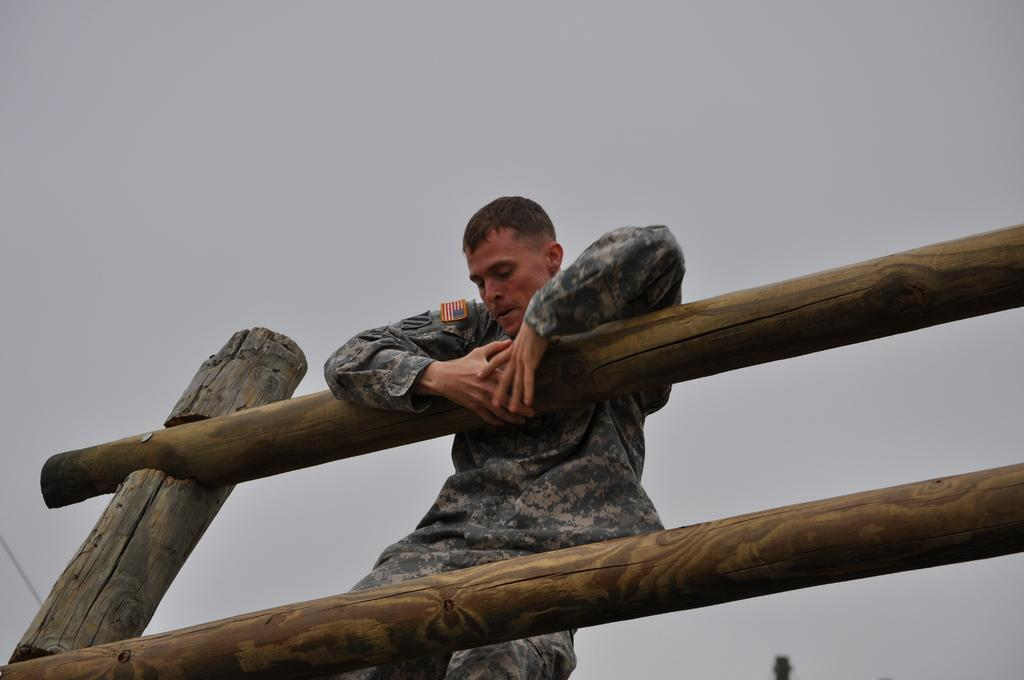What type of structure is visible in the image? There is a wooden railing in the image. Can you describe the person near the railing? There is a person standing near the railing. What can be seen in the background of the image? The sky is visible in the background of the image. What type of guitar is the person playing near the railing? There is no guitar present in the image; the person is simply standing near the railing. How many quarters can be seen on the railing in the image? There are no quarters visible on the railing in the image. 